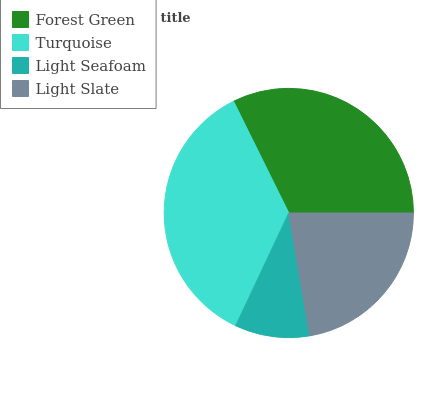Is Light Seafoam the minimum?
Answer yes or no. Yes. Is Turquoise the maximum?
Answer yes or no. Yes. Is Turquoise the minimum?
Answer yes or no. No. Is Light Seafoam the maximum?
Answer yes or no. No. Is Turquoise greater than Light Seafoam?
Answer yes or no. Yes. Is Light Seafoam less than Turquoise?
Answer yes or no. Yes. Is Light Seafoam greater than Turquoise?
Answer yes or no. No. Is Turquoise less than Light Seafoam?
Answer yes or no. No. Is Forest Green the high median?
Answer yes or no. Yes. Is Light Slate the low median?
Answer yes or no. Yes. Is Light Seafoam the high median?
Answer yes or no. No. Is Light Seafoam the low median?
Answer yes or no. No. 